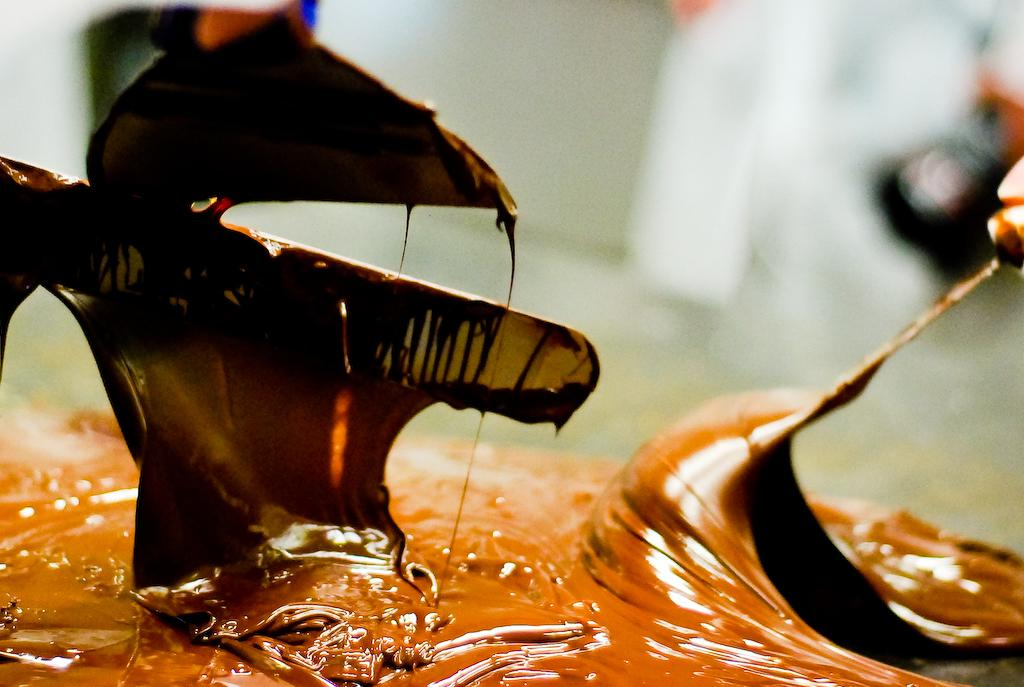What is the substance being mixed in the image? There is chocolate sauce in the image. Who is mixing the chocolate sauce? A person is mixing the chocolate sauce. What utensils are present in the image? Spoons and knives are present in the image. What organization does the maid belong to in the image? There is no maid present in the image, and therefore no organization can be associated with her. 